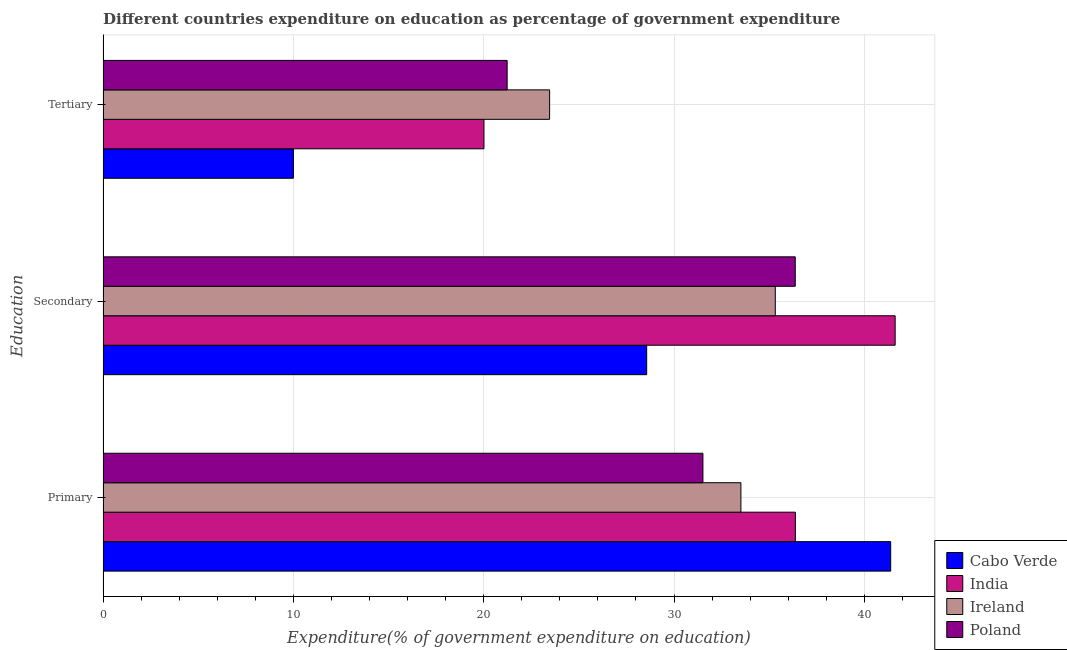How many different coloured bars are there?
Your response must be concise. 4. How many groups of bars are there?
Your response must be concise. 3. Are the number of bars per tick equal to the number of legend labels?
Your answer should be very brief. Yes. How many bars are there on the 2nd tick from the bottom?
Provide a succinct answer. 4. What is the label of the 1st group of bars from the top?
Your answer should be compact. Tertiary. What is the expenditure on tertiary education in Poland?
Offer a very short reply. 21.23. Across all countries, what is the maximum expenditure on tertiary education?
Provide a short and direct response. 23.46. Across all countries, what is the minimum expenditure on secondary education?
Offer a terse response. 28.56. In which country was the expenditure on secondary education maximum?
Provide a short and direct response. India. What is the total expenditure on primary education in the graph?
Provide a short and direct response. 142.79. What is the difference between the expenditure on primary education in Ireland and that in India?
Your response must be concise. -2.86. What is the difference between the expenditure on tertiary education in Poland and the expenditure on secondary education in India?
Make the answer very short. -20.39. What is the average expenditure on tertiary education per country?
Your answer should be compact. 18.68. What is the difference between the expenditure on secondary education and expenditure on tertiary education in Ireland?
Give a very brief answer. 11.86. In how many countries, is the expenditure on tertiary education greater than 16 %?
Provide a short and direct response. 3. What is the ratio of the expenditure on tertiary education in Poland to that in Cabo Verde?
Provide a succinct answer. 2.12. Is the difference between the expenditure on secondary education in India and Cabo Verde greater than the difference between the expenditure on primary education in India and Cabo Verde?
Offer a very short reply. Yes. What is the difference between the highest and the second highest expenditure on primary education?
Ensure brevity in your answer.  5.01. What is the difference between the highest and the lowest expenditure on secondary education?
Keep it short and to the point. 13.06. In how many countries, is the expenditure on primary education greater than the average expenditure on primary education taken over all countries?
Ensure brevity in your answer.  2. What does the 1st bar from the top in Tertiary represents?
Provide a succinct answer. Poland. What does the 3rd bar from the bottom in Secondary represents?
Provide a short and direct response. Ireland. Is it the case that in every country, the sum of the expenditure on primary education and expenditure on secondary education is greater than the expenditure on tertiary education?
Provide a short and direct response. Yes. What is the difference between two consecutive major ticks on the X-axis?
Give a very brief answer. 10. Are the values on the major ticks of X-axis written in scientific E-notation?
Offer a very short reply. No. Does the graph contain any zero values?
Offer a terse response. No. Where does the legend appear in the graph?
Your response must be concise. Bottom right. How many legend labels are there?
Make the answer very short. 4. How are the legend labels stacked?
Give a very brief answer. Vertical. What is the title of the graph?
Offer a terse response. Different countries expenditure on education as percentage of government expenditure. What is the label or title of the X-axis?
Provide a succinct answer. Expenditure(% of government expenditure on education). What is the label or title of the Y-axis?
Provide a succinct answer. Education. What is the Expenditure(% of government expenditure on education) of Cabo Verde in Primary?
Provide a short and direct response. 41.38. What is the Expenditure(% of government expenditure on education) in India in Primary?
Your response must be concise. 36.38. What is the Expenditure(% of government expenditure on education) of Ireland in Primary?
Provide a short and direct response. 33.51. What is the Expenditure(% of government expenditure on education) of Poland in Primary?
Offer a terse response. 31.52. What is the Expenditure(% of government expenditure on education) in Cabo Verde in Secondary?
Provide a succinct answer. 28.56. What is the Expenditure(% of government expenditure on education) in India in Secondary?
Make the answer very short. 41.62. What is the Expenditure(% of government expenditure on education) in Ireland in Secondary?
Give a very brief answer. 35.32. What is the Expenditure(% of government expenditure on education) in Poland in Secondary?
Your answer should be compact. 36.37. What is the Expenditure(% of government expenditure on education) of Cabo Verde in Tertiary?
Offer a terse response. 10. What is the Expenditure(% of government expenditure on education) in India in Tertiary?
Your response must be concise. 20.01. What is the Expenditure(% of government expenditure on education) of Ireland in Tertiary?
Offer a terse response. 23.46. What is the Expenditure(% of government expenditure on education) of Poland in Tertiary?
Your response must be concise. 21.23. Across all Education, what is the maximum Expenditure(% of government expenditure on education) of Cabo Verde?
Make the answer very short. 41.38. Across all Education, what is the maximum Expenditure(% of government expenditure on education) in India?
Offer a very short reply. 41.62. Across all Education, what is the maximum Expenditure(% of government expenditure on education) in Ireland?
Keep it short and to the point. 35.32. Across all Education, what is the maximum Expenditure(% of government expenditure on education) in Poland?
Your answer should be compact. 36.37. Across all Education, what is the minimum Expenditure(% of government expenditure on education) in Cabo Verde?
Offer a very short reply. 10. Across all Education, what is the minimum Expenditure(% of government expenditure on education) in India?
Offer a terse response. 20.01. Across all Education, what is the minimum Expenditure(% of government expenditure on education) of Ireland?
Your response must be concise. 23.46. Across all Education, what is the minimum Expenditure(% of government expenditure on education) of Poland?
Offer a very short reply. 21.23. What is the total Expenditure(% of government expenditure on education) in Cabo Verde in the graph?
Make the answer very short. 79.95. What is the total Expenditure(% of government expenditure on education) in India in the graph?
Your response must be concise. 98.01. What is the total Expenditure(% of government expenditure on education) in Ireland in the graph?
Your answer should be compact. 92.3. What is the total Expenditure(% of government expenditure on education) of Poland in the graph?
Your answer should be compact. 89.12. What is the difference between the Expenditure(% of government expenditure on education) of Cabo Verde in Primary and that in Secondary?
Your response must be concise. 12.82. What is the difference between the Expenditure(% of government expenditure on education) in India in Primary and that in Secondary?
Give a very brief answer. -5.24. What is the difference between the Expenditure(% of government expenditure on education) in Ireland in Primary and that in Secondary?
Offer a very short reply. -1.81. What is the difference between the Expenditure(% of government expenditure on education) of Poland in Primary and that in Secondary?
Provide a short and direct response. -4.85. What is the difference between the Expenditure(% of government expenditure on education) of Cabo Verde in Primary and that in Tertiary?
Make the answer very short. 31.39. What is the difference between the Expenditure(% of government expenditure on education) in India in Primary and that in Tertiary?
Make the answer very short. 16.36. What is the difference between the Expenditure(% of government expenditure on education) in Ireland in Primary and that in Tertiary?
Your response must be concise. 10.05. What is the difference between the Expenditure(% of government expenditure on education) in Poland in Primary and that in Tertiary?
Keep it short and to the point. 10.29. What is the difference between the Expenditure(% of government expenditure on education) of Cabo Verde in Secondary and that in Tertiary?
Give a very brief answer. 18.56. What is the difference between the Expenditure(% of government expenditure on education) of India in Secondary and that in Tertiary?
Offer a terse response. 21.61. What is the difference between the Expenditure(% of government expenditure on education) of Ireland in Secondary and that in Tertiary?
Your response must be concise. 11.86. What is the difference between the Expenditure(% of government expenditure on education) of Poland in Secondary and that in Tertiary?
Offer a terse response. 15.14. What is the difference between the Expenditure(% of government expenditure on education) of Cabo Verde in Primary and the Expenditure(% of government expenditure on education) of India in Secondary?
Make the answer very short. -0.23. What is the difference between the Expenditure(% of government expenditure on education) of Cabo Verde in Primary and the Expenditure(% of government expenditure on education) of Ireland in Secondary?
Give a very brief answer. 6.06. What is the difference between the Expenditure(% of government expenditure on education) in Cabo Verde in Primary and the Expenditure(% of government expenditure on education) in Poland in Secondary?
Your answer should be compact. 5.01. What is the difference between the Expenditure(% of government expenditure on education) in India in Primary and the Expenditure(% of government expenditure on education) in Ireland in Secondary?
Your answer should be compact. 1.05. What is the difference between the Expenditure(% of government expenditure on education) in India in Primary and the Expenditure(% of government expenditure on education) in Poland in Secondary?
Offer a terse response. 0. What is the difference between the Expenditure(% of government expenditure on education) of Ireland in Primary and the Expenditure(% of government expenditure on education) of Poland in Secondary?
Give a very brief answer. -2.86. What is the difference between the Expenditure(% of government expenditure on education) of Cabo Verde in Primary and the Expenditure(% of government expenditure on education) of India in Tertiary?
Your answer should be compact. 21.37. What is the difference between the Expenditure(% of government expenditure on education) of Cabo Verde in Primary and the Expenditure(% of government expenditure on education) of Ireland in Tertiary?
Keep it short and to the point. 17.92. What is the difference between the Expenditure(% of government expenditure on education) of Cabo Verde in Primary and the Expenditure(% of government expenditure on education) of Poland in Tertiary?
Keep it short and to the point. 20.15. What is the difference between the Expenditure(% of government expenditure on education) of India in Primary and the Expenditure(% of government expenditure on education) of Ireland in Tertiary?
Your answer should be very brief. 12.91. What is the difference between the Expenditure(% of government expenditure on education) of India in Primary and the Expenditure(% of government expenditure on education) of Poland in Tertiary?
Your response must be concise. 15.14. What is the difference between the Expenditure(% of government expenditure on education) in Ireland in Primary and the Expenditure(% of government expenditure on education) in Poland in Tertiary?
Provide a short and direct response. 12.28. What is the difference between the Expenditure(% of government expenditure on education) of Cabo Verde in Secondary and the Expenditure(% of government expenditure on education) of India in Tertiary?
Ensure brevity in your answer.  8.55. What is the difference between the Expenditure(% of government expenditure on education) in Cabo Verde in Secondary and the Expenditure(% of government expenditure on education) in Ireland in Tertiary?
Your response must be concise. 5.1. What is the difference between the Expenditure(% of government expenditure on education) in Cabo Verde in Secondary and the Expenditure(% of government expenditure on education) in Poland in Tertiary?
Provide a short and direct response. 7.33. What is the difference between the Expenditure(% of government expenditure on education) of India in Secondary and the Expenditure(% of government expenditure on education) of Ireland in Tertiary?
Make the answer very short. 18.16. What is the difference between the Expenditure(% of government expenditure on education) of India in Secondary and the Expenditure(% of government expenditure on education) of Poland in Tertiary?
Keep it short and to the point. 20.39. What is the difference between the Expenditure(% of government expenditure on education) in Ireland in Secondary and the Expenditure(% of government expenditure on education) in Poland in Tertiary?
Your answer should be very brief. 14.09. What is the average Expenditure(% of government expenditure on education) in Cabo Verde per Education?
Offer a very short reply. 26.65. What is the average Expenditure(% of government expenditure on education) of India per Education?
Give a very brief answer. 32.67. What is the average Expenditure(% of government expenditure on education) of Ireland per Education?
Offer a terse response. 30.77. What is the average Expenditure(% of government expenditure on education) of Poland per Education?
Provide a short and direct response. 29.71. What is the difference between the Expenditure(% of government expenditure on education) of Cabo Verde and Expenditure(% of government expenditure on education) of India in Primary?
Offer a very short reply. 5.01. What is the difference between the Expenditure(% of government expenditure on education) in Cabo Verde and Expenditure(% of government expenditure on education) in Ireland in Primary?
Your answer should be very brief. 7.87. What is the difference between the Expenditure(% of government expenditure on education) in Cabo Verde and Expenditure(% of government expenditure on education) in Poland in Primary?
Offer a terse response. 9.87. What is the difference between the Expenditure(% of government expenditure on education) in India and Expenditure(% of government expenditure on education) in Ireland in Primary?
Your response must be concise. 2.86. What is the difference between the Expenditure(% of government expenditure on education) of India and Expenditure(% of government expenditure on education) of Poland in Primary?
Your answer should be compact. 4.86. What is the difference between the Expenditure(% of government expenditure on education) of Ireland and Expenditure(% of government expenditure on education) of Poland in Primary?
Your answer should be compact. 2. What is the difference between the Expenditure(% of government expenditure on education) in Cabo Verde and Expenditure(% of government expenditure on education) in India in Secondary?
Offer a very short reply. -13.06. What is the difference between the Expenditure(% of government expenditure on education) in Cabo Verde and Expenditure(% of government expenditure on education) in Ireland in Secondary?
Offer a very short reply. -6.76. What is the difference between the Expenditure(% of government expenditure on education) in Cabo Verde and Expenditure(% of government expenditure on education) in Poland in Secondary?
Your answer should be very brief. -7.81. What is the difference between the Expenditure(% of government expenditure on education) in India and Expenditure(% of government expenditure on education) in Ireland in Secondary?
Provide a short and direct response. 6.3. What is the difference between the Expenditure(% of government expenditure on education) in India and Expenditure(% of government expenditure on education) in Poland in Secondary?
Ensure brevity in your answer.  5.25. What is the difference between the Expenditure(% of government expenditure on education) of Ireland and Expenditure(% of government expenditure on education) of Poland in Secondary?
Your answer should be compact. -1.05. What is the difference between the Expenditure(% of government expenditure on education) of Cabo Verde and Expenditure(% of government expenditure on education) of India in Tertiary?
Your answer should be compact. -10.01. What is the difference between the Expenditure(% of government expenditure on education) in Cabo Verde and Expenditure(% of government expenditure on education) in Ireland in Tertiary?
Keep it short and to the point. -13.46. What is the difference between the Expenditure(% of government expenditure on education) in Cabo Verde and Expenditure(% of government expenditure on education) in Poland in Tertiary?
Provide a short and direct response. -11.23. What is the difference between the Expenditure(% of government expenditure on education) of India and Expenditure(% of government expenditure on education) of Ireland in Tertiary?
Make the answer very short. -3.45. What is the difference between the Expenditure(% of government expenditure on education) in India and Expenditure(% of government expenditure on education) in Poland in Tertiary?
Make the answer very short. -1.22. What is the difference between the Expenditure(% of government expenditure on education) in Ireland and Expenditure(% of government expenditure on education) in Poland in Tertiary?
Keep it short and to the point. 2.23. What is the ratio of the Expenditure(% of government expenditure on education) in Cabo Verde in Primary to that in Secondary?
Provide a short and direct response. 1.45. What is the ratio of the Expenditure(% of government expenditure on education) of India in Primary to that in Secondary?
Give a very brief answer. 0.87. What is the ratio of the Expenditure(% of government expenditure on education) in Ireland in Primary to that in Secondary?
Provide a short and direct response. 0.95. What is the ratio of the Expenditure(% of government expenditure on education) of Poland in Primary to that in Secondary?
Keep it short and to the point. 0.87. What is the ratio of the Expenditure(% of government expenditure on education) of Cabo Verde in Primary to that in Tertiary?
Keep it short and to the point. 4.14. What is the ratio of the Expenditure(% of government expenditure on education) of India in Primary to that in Tertiary?
Give a very brief answer. 1.82. What is the ratio of the Expenditure(% of government expenditure on education) of Ireland in Primary to that in Tertiary?
Provide a short and direct response. 1.43. What is the ratio of the Expenditure(% of government expenditure on education) in Poland in Primary to that in Tertiary?
Ensure brevity in your answer.  1.48. What is the ratio of the Expenditure(% of government expenditure on education) of Cabo Verde in Secondary to that in Tertiary?
Ensure brevity in your answer.  2.86. What is the ratio of the Expenditure(% of government expenditure on education) in India in Secondary to that in Tertiary?
Your response must be concise. 2.08. What is the ratio of the Expenditure(% of government expenditure on education) in Ireland in Secondary to that in Tertiary?
Offer a very short reply. 1.51. What is the ratio of the Expenditure(% of government expenditure on education) in Poland in Secondary to that in Tertiary?
Offer a very short reply. 1.71. What is the difference between the highest and the second highest Expenditure(% of government expenditure on education) in Cabo Verde?
Offer a terse response. 12.82. What is the difference between the highest and the second highest Expenditure(% of government expenditure on education) in India?
Your response must be concise. 5.24. What is the difference between the highest and the second highest Expenditure(% of government expenditure on education) of Ireland?
Offer a terse response. 1.81. What is the difference between the highest and the second highest Expenditure(% of government expenditure on education) of Poland?
Give a very brief answer. 4.85. What is the difference between the highest and the lowest Expenditure(% of government expenditure on education) in Cabo Verde?
Make the answer very short. 31.39. What is the difference between the highest and the lowest Expenditure(% of government expenditure on education) of India?
Give a very brief answer. 21.61. What is the difference between the highest and the lowest Expenditure(% of government expenditure on education) in Ireland?
Provide a succinct answer. 11.86. What is the difference between the highest and the lowest Expenditure(% of government expenditure on education) in Poland?
Keep it short and to the point. 15.14. 